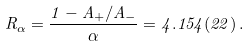Convert formula to latex. <formula><loc_0><loc_0><loc_500><loc_500>R _ { \alpha } = \frac { 1 - A _ { + } / A _ { - } } { \alpha } = 4 . 1 5 4 ( 2 2 ) \, .</formula> 